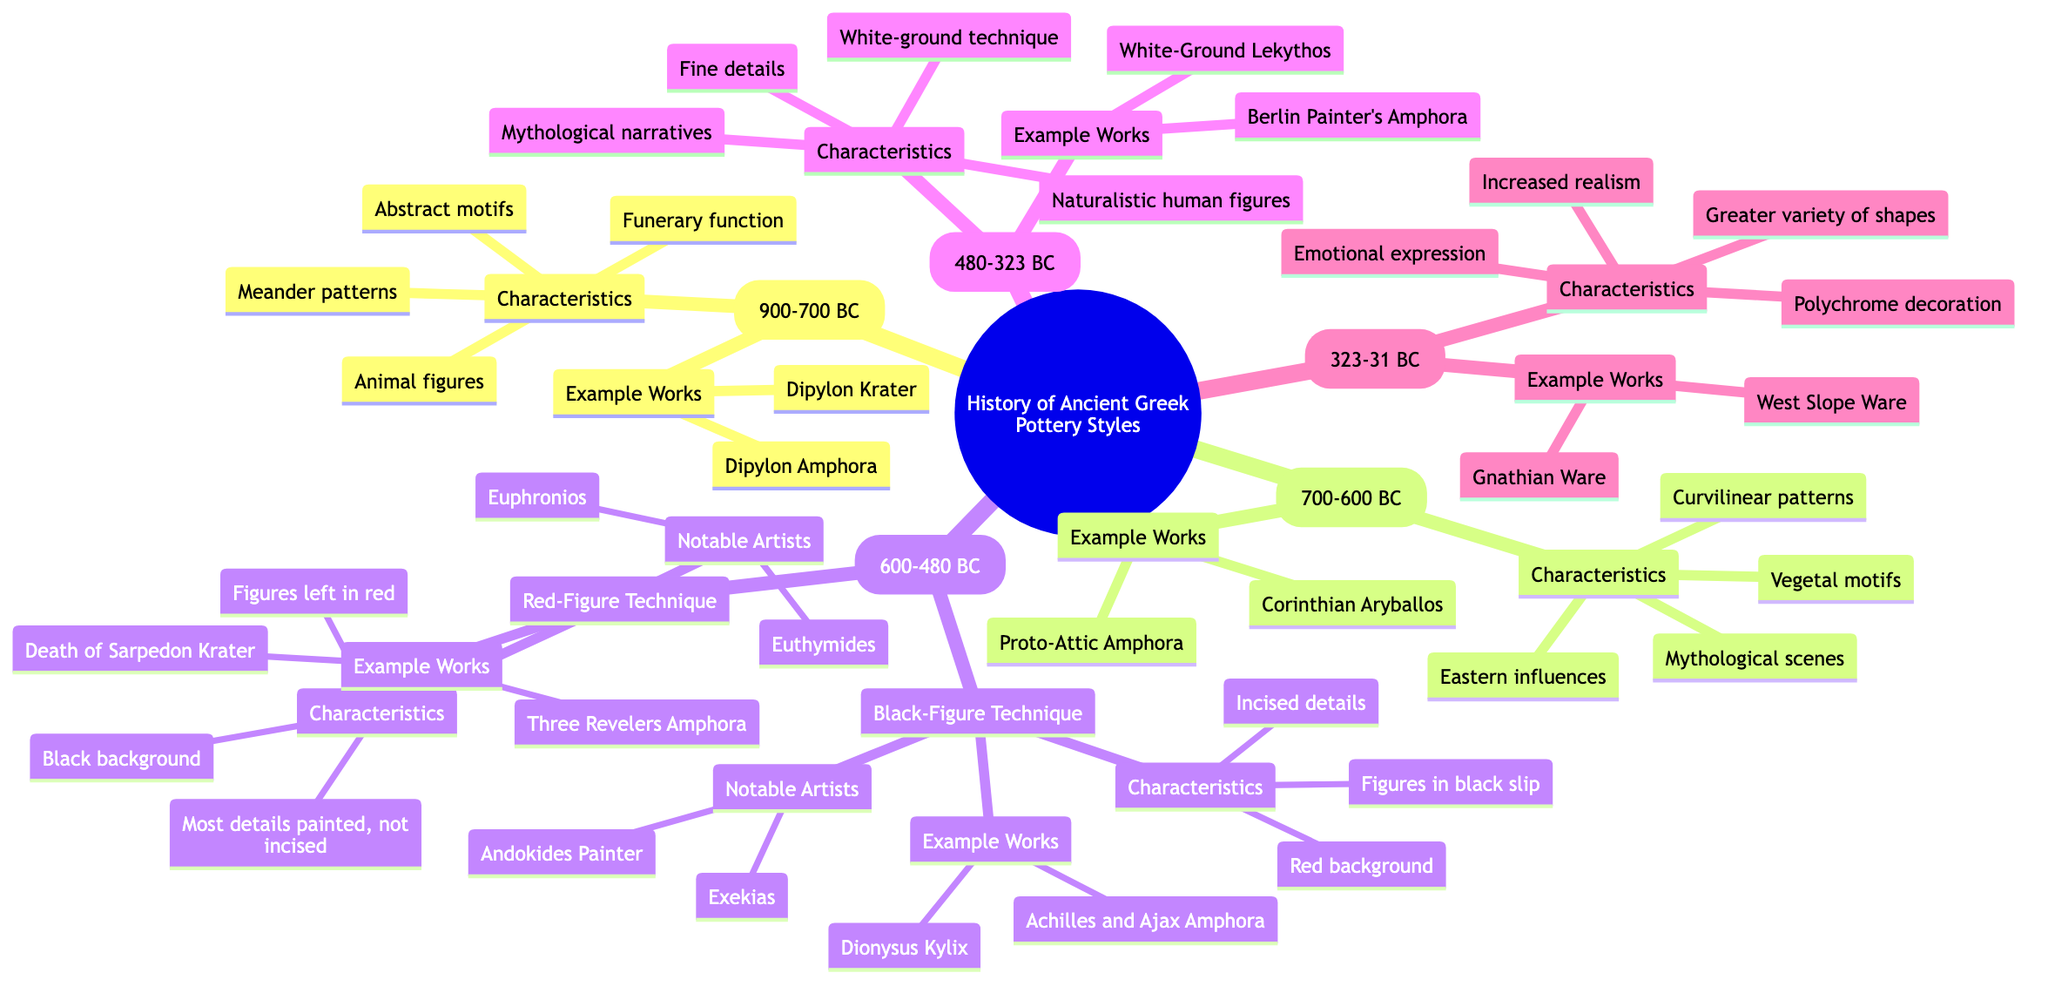What is one characteristic of the Geometric Period? The Geometric Period includes several characteristics; one of them is "Abstract motifs." It is found directly under the Geometric Period node in the diagram.
Answer: Abstract motifs How many notable artists are listed for the Black-Figure Technique? Under the Black-Figure Technique, there are two notable artists mentioned: Exekias and Andokides Painter. This information is summarized in a single node which specifies the artists.
Answer: 2 Which period comes after the Archaic Period? The diagram shows that the Archaic Period is directly followed by the Classical Period, as they are structured sequentially in the hierarchy of the mind map.
Answer: Classical Period What are the characteristics of the Red-Figure Technique? The Red-Figure Technique includes three characteristics: "Figures left in red," "Black background," and "Most details painted, not incised." These details can be found under the respective node.
Answer: Figures left in red, Black background, Most details painted, not incised Which example work is associated with the Hellenistic Period? Under the Hellenistic Period, two example works are provided: Gnathian Ware and West Slope Ware. Both works are listed as examples of this period.
Answer: Gnathian Ware, West Slope Ware What notable artists are associated with the Red-Figure Technique? The Red-Figure Technique lists two notable artists: Euphronios and Euthymides. This information is explicit under the Red-Figure Technique node.
Answer: Euphronios, Euthymides Which period is characterized by increased realism and emotional expression? The characteristics of increased realism and emotional expression are explicitly listed under the Hellenistic Period node in the diagram.
Answer: Hellenistic Period How many pottery styles are mentioned under the Archaic Period? The Archaic Period consists of two styles: Black-Figure Technique and Red-Figure Technique, as indicated by the two subdivisions under the Archaic Period node.
Answer: 2 